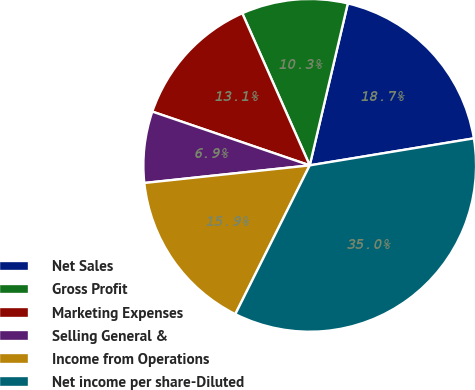Convert chart to OTSL. <chart><loc_0><loc_0><loc_500><loc_500><pie_chart><fcel>Net Sales<fcel>Gross Profit<fcel>Marketing Expenses<fcel>Selling General &<fcel>Income from Operations<fcel>Net income per share-Diluted<nl><fcel>18.73%<fcel>10.32%<fcel>13.12%<fcel>6.93%<fcel>15.93%<fcel>34.98%<nl></chart> 